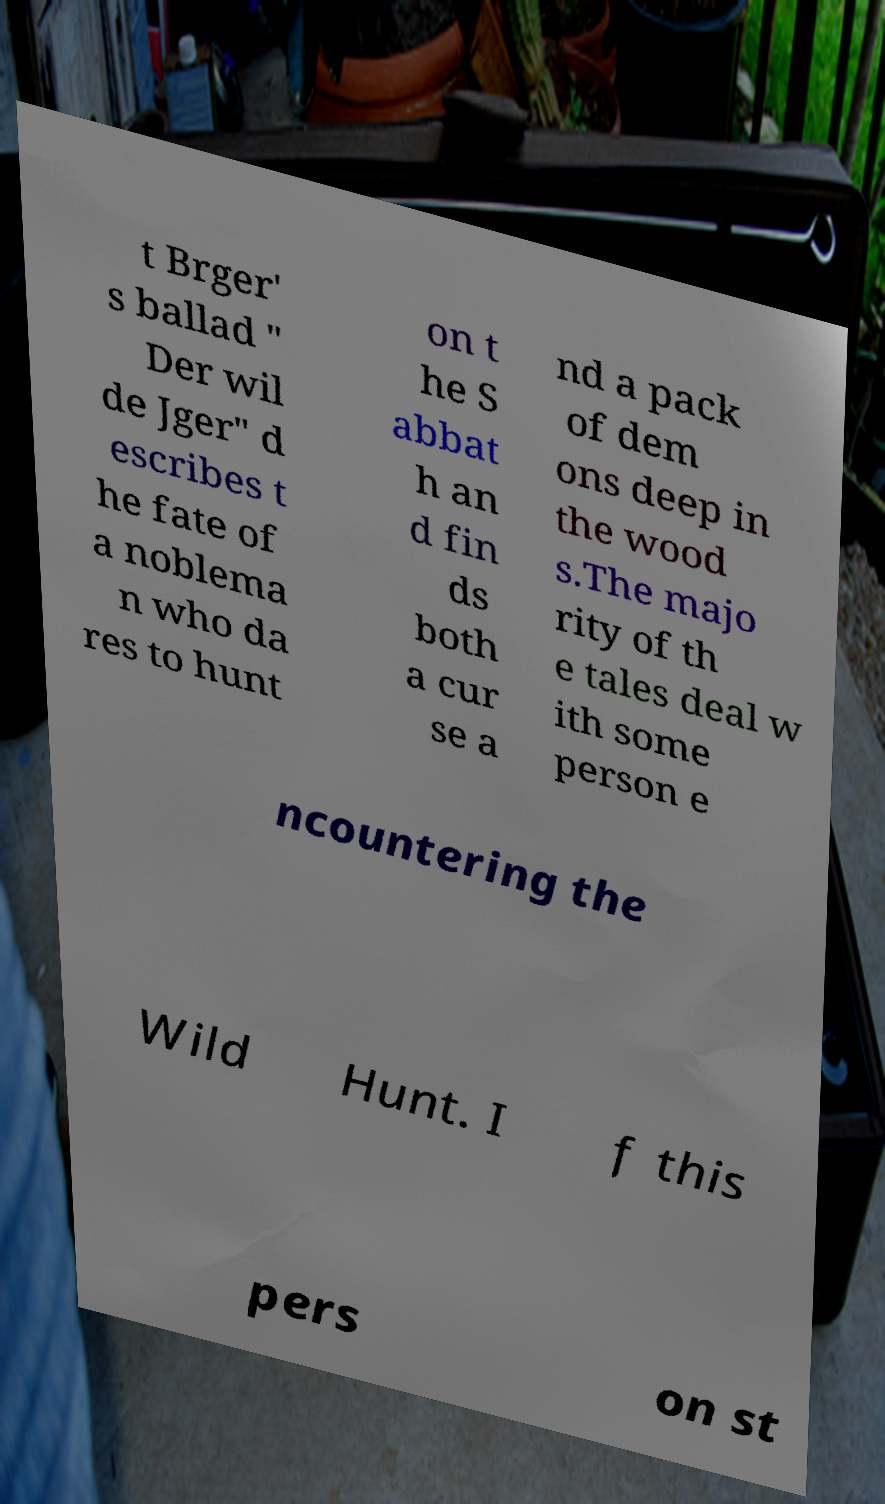Please read and relay the text visible in this image. What does it say? t Brger' s ballad " Der wil de Jger" d escribes t he fate of a noblema n who da res to hunt on t he S abbat h an d fin ds both a cur se a nd a pack of dem ons deep in the wood s.The majo rity of th e tales deal w ith some person e ncountering the Wild Hunt. I f this pers on st 